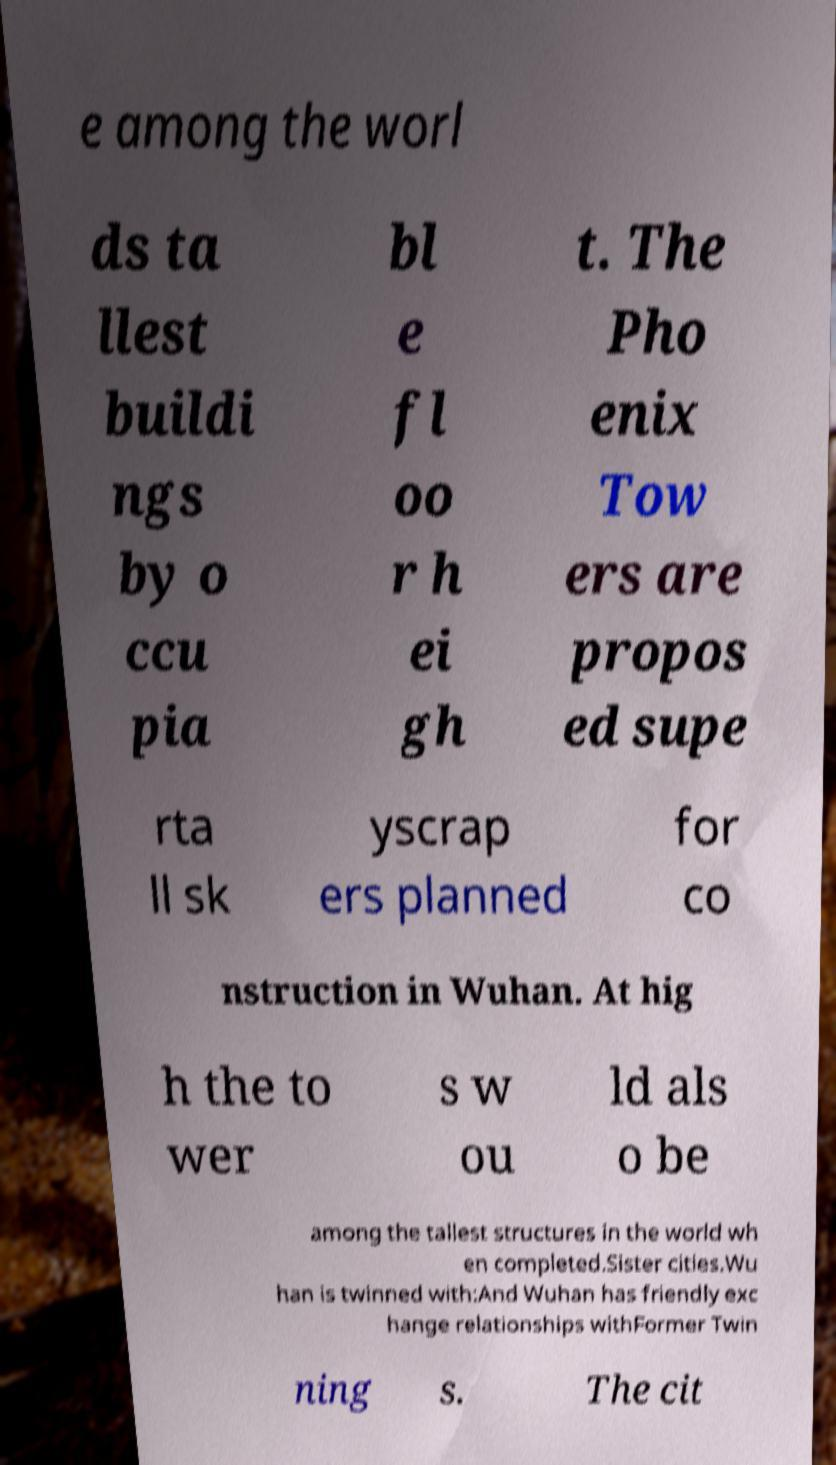For documentation purposes, I need the text within this image transcribed. Could you provide that? e among the worl ds ta llest buildi ngs by o ccu pia bl e fl oo r h ei gh t. The Pho enix Tow ers are propos ed supe rta ll sk yscrap ers planned for co nstruction in Wuhan. At hig h the to wer s w ou ld als o be among the tallest structures in the world wh en completed.Sister cities.Wu han is twinned with:And Wuhan has friendly exc hange relationships withFormer Twin ning s. The cit 